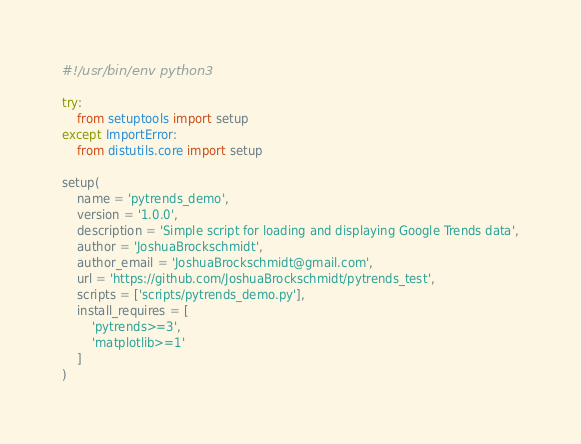<code> <loc_0><loc_0><loc_500><loc_500><_Python_>#!/usr/bin/env python3

try:
    from setuptools import setup
except ImportError:
    from distutils.core import setup

setup(
    name = 'pytrends_demo',
    version = '1.0.0',
    description = 'Simple script for loading and displaying Google Trends data',
    author = 'JoshuaBrockschmidt',
    author_email = 'JoshuaBrockschmidt@gmail.com',
    url = 'https://github.com/JoshuaBrockschmidt/pytrends_test',
    scripts = ['scripts/pytrends_demo.py'],
    install_requires = [
        'pytrends>=3',
        'matplotlib>=1'
    ]
)
</code> 